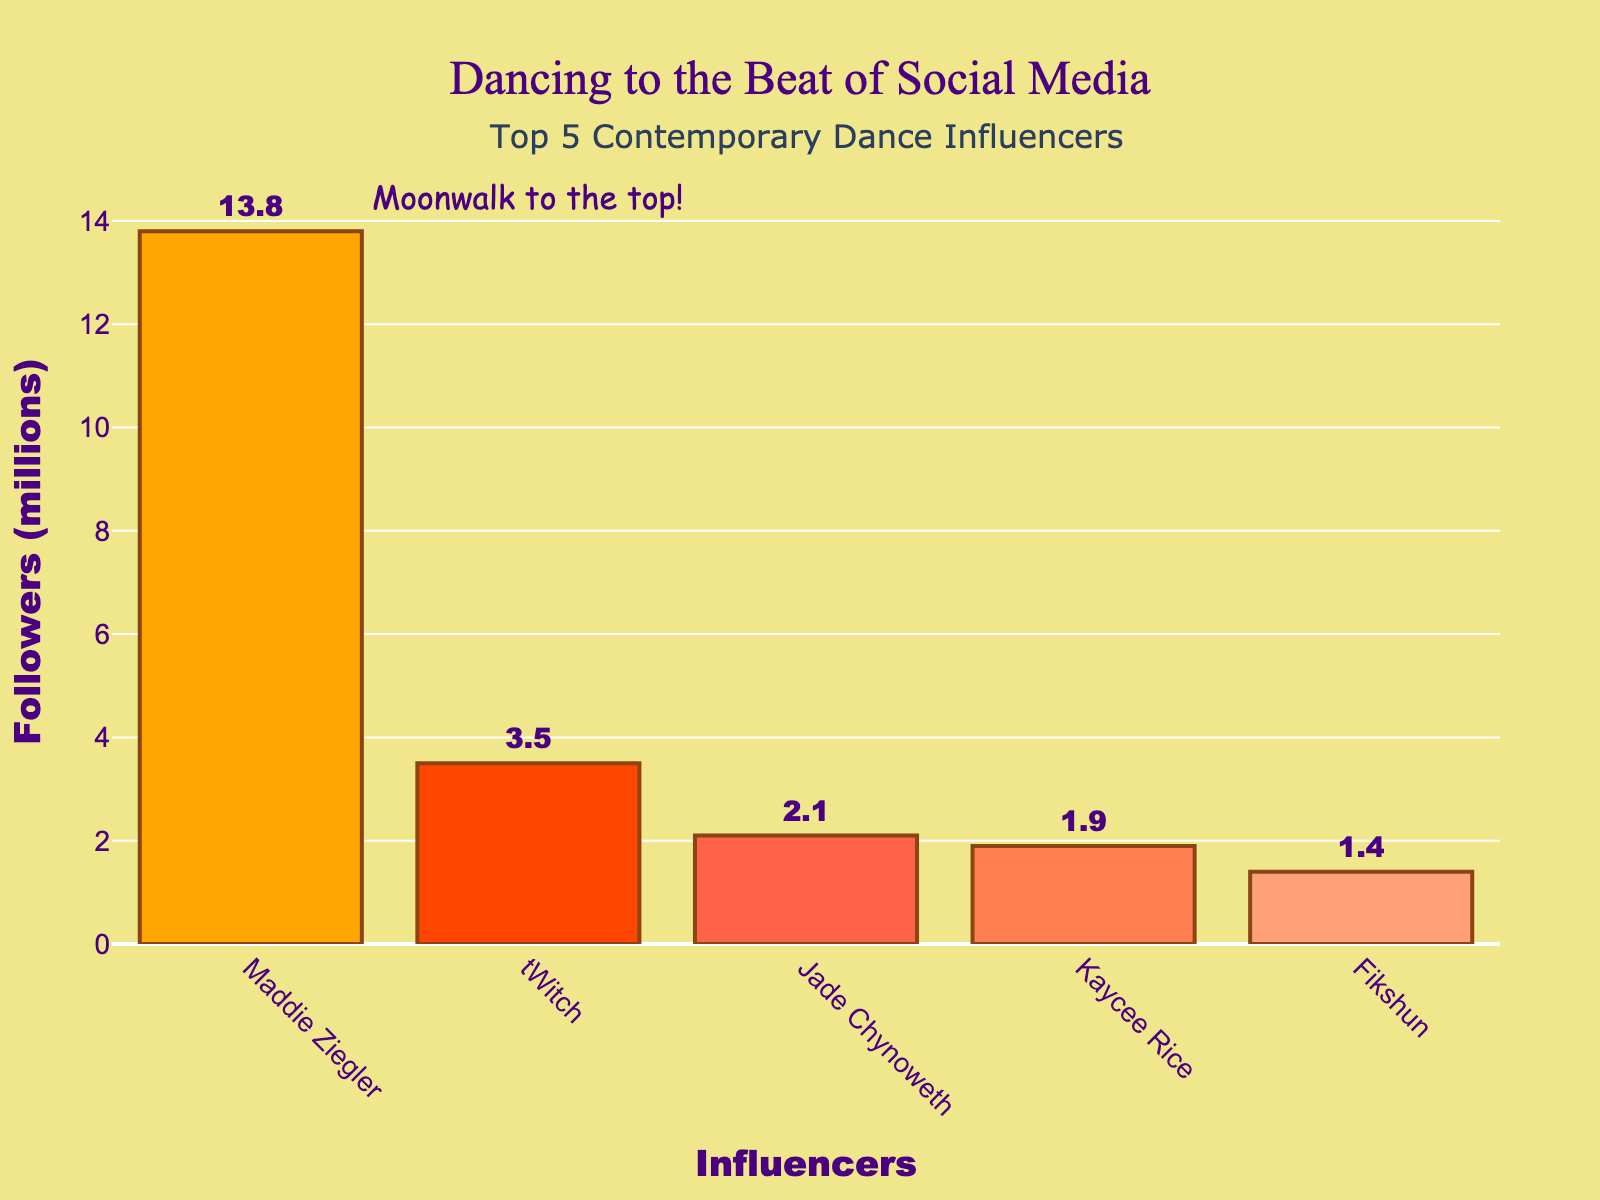What is the total number of followers for all five influencers together? To find the total number of followers, add up the followers of each influencer: 13.8 + 3.5 + 2.1 + 1.9 + 1.4 = 22.7 million.
Answer: 22.7 million Which influencer has the highest number of followers? By examining the figure, Maddie Ziegler has the highest number of followers at 13.8 million.
Answer: Maddie Ziegler Who has fewer followers, Kaycee Rice or Fikshun, and by how many million? Kaycee Rice has 1.9 million followers, and Fikshun has 1.4 million. The difference is 1.9 - 1.4 = 0.5 million.
Answer: Fikshun, by 0.5 million What is the average number of followers for the five influencers? The total number of followers is 22.7 million. To find the average, divide this by the number of influencers: 22.7 / 5 = 4.54 million.
Answer: 4.54 million Compare the follower counts of tWitch and Jade Chynoweth. Who has more followers and by how much? tWitch has 3.5 million followers and Jade Chynoweth has 2.1 million followers. The difference is 3.5 - 2.1 = 1.4 million.
Answer: tWitch, by 1.4 million What are the colors of the bars representing Jade Chynoweth and Kaycee Rice? The bars for Jade Chynoweth and Kaycee Rice are colored red and coral, respectively.
Answer: Red and coral What percentage of the total followers do Maddie Ziegler's followers represent? Maddie Ziegler has 13.8 million followers out of a total of 22.7 million. The percentage is (13.8 / 22.7) * 100 = approximately 60.79%.
Answer: Approximately 60.79% If tWitch gains 1 million followers, how will his new follower count compare to Jade Chynoweth's? Adding 1 million followers to tWitch's current 3.5 million would give him 4.5 million. This would be 4.5 - 2.1 = 2.4 million more than Jade Chynoweth's 2.1 million followers.
Answer: 2.4 million more Which two influencers have the smallest difference in their follower counts, and what is the difference? Kaycee Rice has 1.9 million followers and Fikshun has 1.4 million followers. The smallest difference is between Kaycee Rice and Fikshun, which is 1.9 - 1.4 = 0.5 million.
Answer: Kaycee Rice and Fikshun, 0.5 million If you combine the followers of the three influencers with the fewest followers, what would be the total? Jade Chynoweth (2.1 million), Kaycee Rice (1.9 million), and Fikshun (1.4 million) have followers totaling 2.1 + 1.9 + 1.4 = 5.4 million.
Answer: 5.4 million 